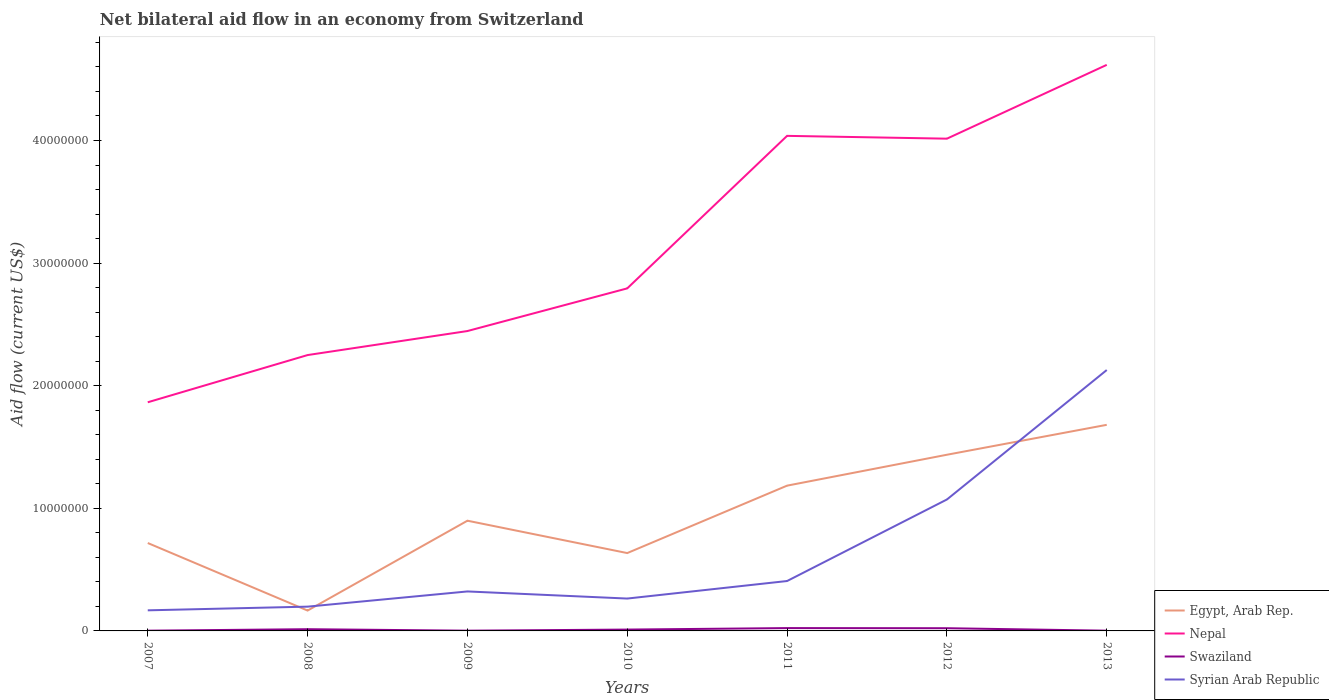How many different coloured lines are there?
Provide a succinct answer. 4. Does the line corresponding to Syrian Arab Republic intersect with the line corresponding to Swaziland?
Ensure brevity in your answer.  No. What is the total net bilateral aid flow in Egypt, Arab Rep. in the graph?
Offer a terse response. -1.82e+06. What is the difference between the highest and the second highest net bilateral aid flow in Egypt, Arab Rep.?
Give a very brief answer. 1.52e+07. Is the net bilateral aid flow in Swaziland strictly greater than the net bilateral aid flow in Egypt, Arab Rep. over the years?
Offer a terse response. Yes. What is the difference between two consecutive major ticks on the Y-axis?
Provide a short and direct response. 1.00e+07. Does the graph contain any zero values?
Give a very brief answer. No. Does the graph contain grids?
Provide a short and direct response. No. How are the legend labels stacked?
Offer a very short reply. Vertical. What is the title of the graph?
Give a very brief answer. Net bilateral aid flow in an economy from Switzerland. What is the Aid flow (current US$) of Egypt, Arab Rep. in 2007?
Give a very brief answer. 7.17e+06. What is the Aid flow (current US$) of Nepal in 2007?
Provide a short and direct response. 1.86e+07. What is the Aid flow (current US$) of Swaziland in 2007?
Give a very brief answer. 2.00e+04. What is the Aid flow (current US$) in Syrian Arab Republic in 2007?
Make the answer very short. 1.68e+06. What is the Aid flow (current US$) of Egypt, Arab Rep. in 2008?
Keep it short and to the point. 1.66e+06. What is the Aid flow (current US$) in Nepal in 2008?
Give a very brief answer. 2.25e+07. What is the Aid flow (current US$) of Syrian Arab Republic in 2008?
Provide a succinct answer. 1.98e+06. What is the Aid flow (current US$) of Egypt, Arab Rep. in 2009?
Keep it short and to the point. 8.99e+06. What is the Aid flow (current US$) in Nepal in 2009?
Offer a very short reply. 2.45e+07. What is the Aid flow (current US$) of Swaziland in 2009?
Make the answer very short. 2.00e+04. What is the Aid flow (current US$) of Syrian Arab Republic in 2009?
Provide a succinct answer. 3.22e+06. What is the Aid flow (current US$) in Egypt, Arab Rep. in 2010?
Provide a short and direct response. 6.35e+06. What is the Aid flow (current US$) in Nepal in 2010?
Your answer should be compact. 2.79e+07. What is the Aid flow (current US$) in Syrian Arab Republic in 2010?
Keep it short and to the point. 2.64e+06. What is the Aid flow (current US$) in Egypt, Arab Rep. in 2011?
Your response must be concise. 1.18e+07. What is the Aid flow (current US$) of Nepal in 2011?
Your answer should be very brief. 4.04e+07. What is the Aid flow (current US$) of Syrian Arab Republic in 2011?
Your answer should be very brief. 4.07e+06. What is the Aid flow (current US$) of Egypt, Arab Rep. in 2012?
Offer a very short reply. 1.44e+07. What is the Aid flow (current US$) in Nepal in 2012?
Your answer should be very brief. 4.02e+07. What is the Aid flow (current US$) in Swaziland in 2012?
Your answer should be very brief. 2.20e+05. What is the Aid flow (current US$) in Syrian Arab Republic in 2012?
Provide a succinct answer. 1.07e+07. What is the Aid flow (current US$) of Egypt, Arab Rep. in 2013?
Provide a succinct answer. 1.68e+07. What is the Aid flow (current US$) of Nepal in 2013?
Provide a succinct answer. 4.62e+07. What is the Aid flow (current US$) of Swaziland in 2013?
Your answer should be compact. 2.00e+04. What is the Aid flow (current US$) of Syrian Arab Republic in 2013?
Your answer should be compact. 2.13e+07. Across all years, what is the maximum Aid flow (current US$) of Egypt, Arab Rep.?
Your answer should be compact. 1.68e+07. Across all years, what is the maximum Aid flow (current US$) of Nepal?
Offer a terse response. 4.62e+07. Across all years, what is the maximum Aid flow (current US$) of Syrian Arab Republic?
Make the answer very short. 2.13e+07. Across all years, what is the minimum Aid flow (current US$) of Egypt, Arab Rep.?
Offer a very short reply. 1.66e+06. Across all years, what is the minimum Aid flow (current US$) in Nepal?
Provide a succinct answer. 1.86e+07. Across all years, what is the minimum Aid flow (current US$) of Syrian Arab Republic?
Your answer should be very brief. 1.68e+06. What is the total Aid flow (current US$) of Egypt, Arab Rep. in the graph?
Keep it short and to the point. 6.72e+07. What is the total Aid flow (current US$) in Nepal in the graph?
Ensure brevity in your answer.  2.20e+08. What is the total Aid flow (current US$) in Swaziland in the graph?
Your response must be concise. 7.60e+05. What is the total Aid flow (current US$) in Syrian Arab Republic in the graph?
Offer a very short reply. 4.56e+07. What is the difference between the Aid flow (current US$) in Egypt, Arab Rep. in 2007 and that in 2008?
Give a very brief answer. 5.51e+06. What is the difference between the Aid flow (current US$) in Nepal in 2007 and that in 2008?
Offer a very short reply. -3.85e+06. What is the difference between the Aid flow (current US$) of Swaziland in 2007 and that in 2008?
Provide a short and direct response. -1.20e+05. What is the difference between the Aid flow (current US$) of Syrian Arab Republic in 2007 and that in 2008?
Your answer should be very brief. -3.00e+05. What is the difference between the Aid flow (current US$) of Egypt, Arab Rep. in 2007 and that in 2009?
Ensure brevity in your answer.  -1.82e+06. What is the difference between the Aid flow (current US$) in Nepal in 2007 and that in 2009?
Give a very brief answer. -5.81e+06. What is the difference between the Aid flow (current US$) in Swaziland in 2007 and that in 2009?
Offer a very short reply. 0. What is the difference between the Aid flow (current US$) in Syrian Arab Republic in 2007 and that in 2009?
Provide a succinct answer. -1.54e+06. What is the difference between the Aid flow (current US$) of Egypt, Arab Rep. in 2007 and that in 2010?
Provide a short and direct response. 8.20e+05. What is the difference between the Aid flow (current US$) of Nepal in 2007 and that in 2010?
Provide a succinct answer. -9.29e+06. What is the difference between the Aid flow (current US$) of Swaziland in 2007 and that in 2010?
Provide a succinct answer. -9.00e+04. What is the difference between the Aid flow (current US$) of Syrian Arab Republic in 2007 and that in 2010?
Make the answer very short. -9.60e+05. What is the difference between the Aid flow (current US$) in Egypt, Arab Rep. in 2007 and that in 2011?
Your answer should be very brief. -4.68e+06. What is the difference between the Aid flow (current US$) of Nepal in 2007 and that in 2011?
Your answer should be very brief. -2.17e+07. What is the difference between the Aid flow (current US$) in Swaziland in 2007 and that in 2011?
Offer a very short reply. -2.10e+05. What is the difference between the Aid flow (current US$) in Syrian Arab Republic in 2007 and that in 2011?
Offer a terse response. -2.39e+06. What is the difference between the Aid flow (current US$) of Egypt, Arab Rep. in 2007 and that in 2012?
Your answer should be very brief. -7.20e+06. What is the difference between the Aid flow (current US$) in Nepal in 2007 and that in 2012?
Provide a succinct answer. -2.15e+07. What is the difference between the Aid flow (current US$) in Swaziland in 2007 and that in 2012?
Offer a terse response. -2.00e+05. What is the difference between the Aid flow (current US$) in Syrian Arab Republic in 2007 and that in 2012?
Make the answer very short. -9.04e+06. What is the difference between the Aid flow (current US$) of Egypt, Arab Rep. in 2007 and that in 2013?
Make the answer very short. -9.64e+06. What is the difference between the Aid flow (current US$) of Nepal in 2007 and that in 2013?
Give a very brief answer. -2.75e+07. What is the difference between the Aid flow (current US$) in Syrian Arab Republic in 2007 and that in 2013?
Provide a short and direct response. -1.96e+07. What is the difference between the Aid flow (current US$) in Egypt, Arab Rep. in 2008 and that in 2009?
Offer a terse response. -7.33e+06. What is the difference between the Aid flow (current US$) of Nepal in 2008 and that in 2009?
Keep it short and to the point. -1.96e+06. What is the difference between the Aid flow (current US$) of Swaziland in 2008 and that in 2009?
Provide a short and direct response. 1.20e+05. What is the difference between the Aid flow (current US$) of Syrian Arab Republic in 2008 and that in 2009?
Your answer should be very brief. -1.24e+06. What is the difference between the Aid flow (current US$) of Egypt, Arab Rep. in 2008 and that in 2010?
Offer a very short reply. -4.69e+06. What is the difference between the Aid flow (current US$) of Nepal in 2008 and that in 2010?
Offer a terse response. -5.44e+06. What is the difference between the Aid flow (current US$) in Swaziland in 2008 and that in 2010?
Ensure brevity in your answer.  3.00e+04. What is the difference between the Aid flow (current US$) of Syrian Arab Republic in 2008 and that in 2010?
Provide a succinct answer. -6.60e+05. What is the difference between the Aid flow (current US$) of Egypt, Arab Rep. in 2008 and that in 2011?
Provide a short and direct response. -1.02e+07. What is the difference between the Aid flow (current US$) of Nepal in 2008 and that in 2011?
Your answer should be very brief. -1.79e+07. What is the difference between the Aid flow (current US$) in Syrian Arab Republic in 2008 and that in 2011?
Provide a short and direct response. -2.09e+06. What is the difference between the Aid flow (current US$) in Egypt, Arab Rep. in 2008 and that in 2012?
Keep it short and to the point. -1.27e+07. What is the difference between the Aid flow (current US$) in Nepal in 2008 and that in 2012?
Ensure brevity in your answer.  -1.76e+07. What is the difference between the Aid flow (current US$) of Swaziland in 2008 and that in 2012?
Keep it short and to the point. -8.00e+04. What is the difference between the Aid flow (current US$) in Syrian Arab Republic in 2008 and that in 2012?
Make the answer very short. -8.74e+06. What is the difference between the Aid flow (current US$) in Egypt, Arab Rep. in 2008 and that in 2013?
Keep it short and to the point. -1.52e+07. What is the difference between the Aid flow (current US$) in Nepal in 2008 and that in 2013?
Provide a short and direct response. -2.37e+07. What is the difference between the Aid flow (current US$) in Swaziland in 2008 and that in 2013?
Offer a terse response. 1.20e+05. What is the difference between the Aid flow (current US$) in Syrian Arab Republic in 2008 and that in 2013?
Ensure brevity in your answer.  -1.93e+07. What is the difference between the Aid flow (current US$) of Egypt, Arab Rep. in 2009 and that in 2010?
Your response must be concise. 2.64e+06. What is the difference between the Aid flow (current US$) of Nepal in 2009 and that in 2010?
Ensure brevity in your answer.  -3.48e+06. What is the difference between the Aid flow (current US$) in Syrian Arab Republic in 2009 and that in 2010?
Offer a terse response. 5.80e+05. What is the difference between the Aid flow (current US$) of Egypt, Arab Rep. in 2009 and that in 2011?
Your answer should be compact. -2.86e+06. What is the difference between the Aid flow (current US$) of Nepal in 2009 and that in 2011?
Ensure brevity in your answer.  -1.59e+07. What is the difference between the Aid flow (current US$) in Swaziland in 2009 and that in 2011?
Ensure brevity in your answer.  -2.10e+05. What is the difference between the Aid flow (current US$) in Syrian Arab Republic in 2009 and that in 2011?
Give a very brief answer. -8.50e+05. What is the difference between the Aid flow (current US$) in Egypt, Arab Rep. in 2009 and that in 2012?
Keep it short and to the point. -5.38e+06. What is the difference between the Aid flow (current US$) in Nepal in 2009 and that in 2012?
Offer a terse response. -1.57e+07. What is the difference between the Aid flow (current US$) in Syrian Arab Republic in 2009 and that in 2012?
Give a very brief answer. -7.50e+06. What is the difference between the Aid flow (current US$) in Egypt, Arab Rep. in 2009 and that in 2013?
Keep it short and to the point. -7.82e+06. What is the difference between the Aid flow (current US$) in Nepal in 2009 and that in 2013?
Offer a terse response. -2.17e+07. What is the difference between the Aid flow (current US$) of Syrian Arab Republic in 2009 and that in 2013?
Your response must be concise. -1.81e+07. What is the difference between the Aid flow (current US$) of Egypt, Arab Rep. in 2010 and that in 2011?
Give a very brief answer. -5.50e+06. What is the difference between the Aid flow (current US$) of Nepal in 2010 and that in 2011?
Your answer should be very brief. -1.24e+07. What is the difference between the Aid flow (current US$) of Syrian Arab Republic in 2010 and that in 2011?
Ensure brevity in your answer.  -1.43e+06. What is the difference between the Aid flow (current US$) of Egypt, Arab Rep. in 2010 and that in 2012?
Ensure brevity in your answer.  -8.02e+06. What is the difference between the Aid flow (current US$) of Nepal in 2010 and that in 2012?
Your response must be concise. -1.22e+07. What is the difference between the Aid flow (current US$) in Swaziland in 2010 and that in 2012?
Provide a succinct answer. -1.10e+05. What is the difference between the Aid flow (current US$) of Syrian Arab Republic in 2010 and that in 2012?
Keep it short and to the point. -8.08e+06. What is the difference between the Aid flow (current US$) of Egypt, Arab Rep. in 2010 and that in 2013?
Provide a succinct answer. -1.05e+07. What is the difference between the Aid flow (current US$) in Nepal in 2010 and that in 2013?
Offer a terse response. -1.82e+07. What is the difference between the Aid flow (current US$) in Syrian Arab Republic in 2010 and that in 2013?
Offer a terse response. -1.86e+07. What is the difference between the Aid flow (current US$) of Egypt, Arab Rep. in 2011 and that in 2012?
Ensure brevity in your answer.  -2.52e+06. What is the difference between the Aid flow (current US$) of Syrian Arab Republic in 2011 and that in 2012?
Keep it short and to the point. -6.65e+06. What is the difference between the Aid flow (current US$) of Egypt, Arab Rep. in 2011 and that in 2013?
Provide a succinct answer. -4.96e+06. What is the difference between the Aid flow (current US$) in Nepal in 2011 and that in 2013?
Your answer should be very brief. -5.79e+06. What is the difference between the Aid flow (current US$) in Syrian Arab Republic in 2011 and that in 2013?
Provide a short and direct response. -1.72e+07. What is the difference between the Aid flow (current US$) in Egypt, Arab Rep. in 2012 and that in 2013?
Provide a short and direct response. -2.44e+06. What is the difference between the Aid flow (current US$) of Nepal in 2012 and that in 2013?
Offer a terse response. -6.02e+06. What is the difference between the Aid flow (current US$) in Swaziland in 2012 and that in 2013?
Your response must be concise. 2.00e+05. What is the difference between the Aid flow (current US$) in Syrian Arab Republic in 2012 and that in 2013?
Your response must be concise. -1.06e+07. What is the difference between the Aid flow (current US$) in Egypt, Arab Rep. in 2007 and the Aid flow (current US$) in Nepal in 2008?
Provide a short and direct response. -1.53e+07. What is the difference between the Aid flow (current US$) of Egypt, Arab Rep. in 2007 and the Aid flow (current US$) of Swaziland in 2008?
Your response must be concise. 7.03e+06. What is the difference between the Aid flow (current US$) in Egypt, Arab Rep. in 2007 and the Aid flow (current US$) in Syrian Arab Republic in 2008?
Your answer should be very brief. 5.19e+06. What is the difference between the Aid flow (current US$) of Nepal in 2007 and the Aid flow (current US$) of Swaziland in 2008?
Offer a terse response. 1.85e+07. What is the difference between the Aid flow (current US$) in Nepal in 2007 and the Aid flow (current US$) in Syrian Arab Republic in 2008?
Keep it short and to the point. 1.67e+07. What is the difference between the Aid flow (current US$) in Swaziland in 2007 and the Aid flow (current US$) in Syrian Arab Republic in 2008?
Ensure brevity in your answer.  -1.96e+06. What is the difference between the Aid flow (current US$) of Egypt, Arab Rep. in 2007 and the Aid flow (current US$) of Nepal in 2009?
Keep it short and to the point. -1.73e+07. What is the difference between the Aid flow (current US$) in Egypt, Arab Rep. in 2007 and the Aid flow (current US$) in Swaziland in 2009?
Offer a terse response. 7.15e+06. What is the difference between the Aid flow (current US$) of Egypt, Arab Rep. in 2007 and the Aid flow (current US$) of Syrian Arab Republic in 2009?
Your answer should be compact. 3.95e+06. What is the difference between the Aid flow (current US$) of Nepal in 2007 and the Aid flow (current US$) of Swaziland in 2009?
Make the answer very short. 1.86e+07. What is the difference between the Aid flow (current US$) of Nepal in 2007 and the Aid flow (current US$) of Syrian Arab Republic in 2009?
Offer a terse response. 1.54e+07. What is the difference between the Aid flow (current US$) of Swaziland in 2007 and the Aid flow (current US$) of Syrian Arab Republic in 2009?
Your response must be concise. -3.20e+06. What is the difference between the Aid flow (current US$) of Egypt, Arab Rep. in 2007 and the Aid flow (current US$) of Nepal in 2010?
Make the answer very short. -2.08e+07. What is the difference between the Aid flow (current US$) of Egypt, Arab Rep. in 2007 and the Aid flow (current US$) of Swaziland in 2010?
Provide a short and direct response. 7.06e+06. What is the difference between the Aid flow (current US$) in Egypt, Arab Rep. in 2007 and the Aid flow (current US$) in Syrian Arab Republic in 2010?
Your response must be concise. 4.53e+06. What is the difference between the Aid flow (current US$) in Nepal in 2007 and the Aid flow (current US$) in Swaziland in 2010?
Make the answer very short. 1.85e+07. What is the difference between the Aid flow (current US$) in Nepal in 2007 and the Aid flow (current US$) in Syrian Arab Republic in 2010?
Ensure brevity in your answer.  1.60e+07. What is the difference between the Aid flow (current US$) in Swaziland in 2007 and the Aid flow (current US$) in Syrian Arab Republic in 2010?
Make the answer very short. -2.62e+06. What is the difference between the Aid flow (current US$) in Egypt, Arab Rep. in 2007 and the Aid flow (current US$) in Nepal in 2011?
Your answer should be compact. -3.32e+07. What is the difference between the Aid flow (current US$) of Egypt, Arab Rep. in 2007 and the Aid flow (current US$) of Swaziland in 2011?
Ensure brevity in your answer.  6.94e+06. What is the difference between the Aid flow (current US$) in Egypt, Arab Rep. in 2007 and the Aid flow (current US$) in Syrian Arab Republic in 2011?
Offer a terse response. 3.10e+06. What is the difference between the Aid flow (current US$) in Nepal in 2007 and the Aid flow (current US$) in Swaziland in 2011?
Offer a very short reply. 1.84e+07. What is the difference between the Aid flow (current US$) in Nepal in 2007 and the Aid flow (current US$) in Syrian Arab Republic in 2011?
Give a very brief answer. 1.46e+07. What is the difference between the Aid flow (current US$) in Swaziland in 2007 and the Aid flow (current US$) in Syrian Arab Republic in 2011?
Provide a succinct answer. -4.05e+06. What is the difference between the Aid flow (current US$) of Egypt, Arab Rep. in 2007 and the Aid flow (current US$) of Nepal in 2012?
Give a very brief answer. -3.30e+07. What is the difference between the Aid flow (current US$) of Egypt, Arab Rep. in 2007 and the Aid flow (current US$) of Swaziland in 2012?
Provide a succinct answer. 6.95e+06. What is the difference between the Aid flow (current US$) of Egypt, Arab Rep. in 2007 and the Aid flow (current US$) of Syrian Arab Republic in 2012?
Provide a short and direct response. -3.55e+06. What is the difference between the Aid flow (current US$) in Nepal in 2007 and the Aid flow (current US$) in Swaziland in 2012?
Your response must be concise. 1.84e+07. What is the difference between the Aid flow (current US$) of Nepal in 2007 and the Aid flow (current US$) of Syrian Arab Republic in 2012?
Your response must be concise. 7.93e+06. What is the difference between the Aid flow (current US$) in Swaziland in 2007 and the Aid flow (current US$) in Syrian Arab Republic in 2012?
Offer a very short reply. -1.07e+07. What is the difference between the Aid flow (current US$) of Egypt, Arab Rep. in 2007 and the Aid flow (current US$) of Nepal in 2013?
Give a very brief answer. -3.90e+07. What is the difference between the Aid flow (current US$) of Egypt, Arab Rep. in 2007 and the Aid flow (current US$) of Swaziland in 2013?
Offer a terse response. 7.15e+06. What is the difference between the Aid flow (current US$) of Egypt, Arab Rep. in 2007 and the Aid flow (current US$) of Syrian Arab Republic in 2013?
Make the answer very short. -1.41e+07. What is the difference between the Aid flow (current US$) of Nepal in 2007 and the Aid flow (current US$) of Swaziland in 2013?
Your answer should be compact. 1.86e+07. What is the difference between the Aid flow (current US$) of Nepal in 2007 and the Aid flow (current US$) of Syrian Arab Republic in 2013?
Provide a short and direct response. -2.63e+06. What is the difference between the Aid flow (current US$) in Swaziland in 2007 and the Aid flow (current US$) in Syrian Arab Republic in 2013?
Keep it short and to the point. -2.13e+07. What is the difference between the Aid flow (current US$) of Egypt, Arab Rep. in 2008 and the Aid flow (current US$) of Nepal in 2009?
Offer a terse response. -2.28e+07. What is the difference between the Aid flow (current US$) of Egypt, Arab Rep. in 2008 and the Aid flow (current US$) of Swaziland in 2009?
Your response must be concise. 1.64e+06. What is the difference between the Aid flow (current US$) in Egypt, Arab Rep. in 2008 and the Aid flow (current US$) in Syrian Arab Republic in 2009?
Provide a succinct answer. -1.56e+06. What is the difference between the Aid flow (current US$) in Nepal in 2008 and the Aid flow (current US$) in Swaziland in 2009?
Your response must be concise. 2.25e+07. What is the difference between the Aid flow (current US$) in Nepal in 2008 and the Aid flow (current US$) in Syrian Arab Republic in 2009?
Your response must be concise. 1.93e+07. What is the difference between the Aid flow (current US$) of Swaziland in 2008 and the Aid flow (current US$) of Syrian Arab Republic in 2009?
Ensure brevity in your answer.  -3.08e+06. What is the difference between the Aid flow (current US$) in Egypt, Arab Rep. in 2008 and the Aid flow (current US$) in Nepal in 2010?
Offer a terse response. -2.63e+07. What is the difference between the Aid flow (current US$) in Egypt, Arab Rep. in 2008 and the Aid flow (current US$) in Swaziland in 2010?
Your answer should be very brief. 1.55e+06. What is the difference between the Aid flow (current US$) of Egypt, Arab Rep. in 2008 and the Aid flow (current US$) of Syrian Arab Republic in 2010?
Provide a short and direct response. -9.80e+05. What is the difference between the Aid flow (current US$) of Nepal in 2008 and the Aid flow (current US$) of Swaziland in 2010?
Offer a terse response. 2.24e+07. What is the difference between the Aid flow (current US$) of Nepal in 2008 and the Aid flow (current US$) of Syrian Arab Republic in 2010?
Provide a short and direct response. 1.99e+07. What is the difference between the Aid flow (current US$) of Swaziland in 2008 and the Aid flow (current US$) of Syrian Arab Republic in 2010?
Your response must be concise. -2.50e+06. What is the difference between the Aid flow (current US$) of Egypt, Arab Rep. in 2008 and the Aid flow (current US$) of Nepal in 2011?
Make the answer very short. -3.87e+07. What is the difference between the Aid flow (current US$) of Egypt, Arab Rep. in 2008 and the Aid flow (current US$) of Swaziland in 2011?
Ensure brevity in your answer.  1.43e+06. What is the difference between the Aid flow (current US$) of Egypt, Arab Rep. in 2008 and the Aid flow (current US$) of Syrian Arab Republic in 2011?
Your response must be concise. -2.41e+06. What is the difference between the Aid flow (current US$) in Nepal in 2008 and the Aid flow (current US$) in Swaziland in 2011?
Offer a very short reply. 2.23e+07. What is the difference between the Aid flow (current US$) of Nepal in 2008 and the Aid flow (current US$) of Syrian Arab Republic in 2011?
Give a very brief answer. 1.84e+07. What is the difference between the Aid flow (current US$) in Swaziland in 2008 and the Aid flow (current US$) in Syrian Arab Republic in 2011?
Offer a very short reply. -3.93e+06. What is the difference between the Aid flow (current US$) of Egypt, Arab Rep. in 2008 and the Aid flow (current US$) of Nepal in 2012?
Offer a very short reply. -3.85e+07. What is the difference between the Aid flow (current US$) of Egypt, Arab Rep. in 2008 and the Aid flow (current US$) of Swaziland in 2012?
Your answer should be compact. 1.44e+06. What is the difference between the Aid flow (current US$) of Egypt, Arab Rep. in 2008 and the Aid flow (current US$) of Syrian Arab Republic in 2012?
Your answer should be compact. -9.06e+06. What is the difference between the Aid flow (current US$) of Nepal in 2008 and the Aid flow (current US$) of Swaziland in 2012?
Your answer should be very brief. 2.23e+07. What is the difference between the Aid flow (current US$) in Nepal in 2008 and the Aid flow (current US$) in Syrian Arab Republic in 2012?
Provide a short and direct response. 1.18e+07. What is the difference between the Aid flow (current US$) in Swaziland in 2008 and the Aid flow (current US$) in Syrian Arab Republic in 2012?
Your answer should be compact. -1.06e+07. What is the difference between the Aid flow (current US$) of Egypt, Arab Rep. in 2008 and the Aid flow (current US$) of Nepal in 2013?
Your answer should be compact. -4.45e+07. What is the difference between the Aid flow (current US$) in Egypt, Arab Rep. in 2008 and the Aid flow (current US$) in Swaziland in 2013?
Provide a succinct answer. 1.64e+06. What is the difference between the Aid flow (current US$) in Egypt, Arab Rep. in 2008 and the Aid flow (current US$) in Syrian Arab Republic in 2013?
Your answer should be very brief. -1.96e+07. What is the difference between the Aid flow (current US$) in Nepal in 2008 and the Aid flow (current US$) in Swaziland in 2013?
Your response must be concise. 2.25e+07. What is the difference between the Aid flow (current US$) of Nepal in 2008 and the Aid flow (current US$) of Syrian Arab Republic in 2013?
Make the answer very short. 1.22e+06. What is the difference between the Aid flow (current US$) of Swaziland in 2008 and the Aid flow (current US$) of Syrian Arab Republic in 2013?
Provide a short and direct response. -2.11e+07. What is the difference between the Aid flow (current US$) in Egypt, Arab Rep. in 2009 and the Aid flow (current US$) in Nepal in 2010?
Your response must be concise. -1.90e+07. What is the difference between the Aid flow (current US$) in Egypt, Arab Rep. in 2009 and the Aid flow (current US$) in Swaziland in 2010?
Give a very brief answer. 8.88e+06. What is the difference between the Aid flow (current US$) in Egypt, Arab Rep. in 2009 and the Aid flow (current US$) in Syrian Arab Republic in 2010?
Ensure brevity in your answer.  6.35e+06. What is the difference between the Aid flow (current US$) of Nepal in 2009 and the Aid flow (current US$) of Swaziland in 2010?
Your answer should be very brief. 2.44e+07. What is the difference between the Aid flow (current US$) in Nepal in 2009 and the Aid flow (current US$) in Syrian Arab Republic in 2010?
Give a very brief answer. 2.18e+07. What is the difference between the Aid flow (current US$) in Swaziland in 2009 and the Aid flow (current US$) in Syrian Arab Republic in 2010?
Provide a short and direct response. -2.62e+06. What is the difference between the Aid flow (current US$) in Egypt, Arab Rep. in 2009 and the Aid flow (current US$) in Nepal in 2011?
Ensure brevity in your answer.  -3.14e+07. What is the difference between the Aid flow (current US$) of Egypt, Arab Rep. in 2009 and the Aid flow (current US$) of Swaziland in 2011?
Provide a short and direct response. 8.76e+06. What is the difference between the Aid flow (current US$) in Egypt, Arab Rep. in 2009 and the Aid flow (current US$) in Syrian Arab Republic in 2011?
Your answer should be very brief. 4.92e+06. What is the difference between the Aid flow (current US$) of Nepal in 2009 and the Aid flow (current US$) of Swaziland in 2011?
Provide a succinct answer. 2.42e+07. What is the difference between the Aid flow (current US$) in Nepal in 2009 and the Aid flow (current US$) in Syrian Arab Republic in 2011?
Your answer should be very brief. 2.04e+07. What is the difference between the Aid flow (current US$) of Swaziland in 2009 and the Aid flow (current US$) of Syrian Arab Republic in 2011?
Give a very brief answer. -4.05e+06. What is the difference between the Aid flow (current US$) of Egypt, Arab Rep. in 2009 and the Aid flow (current US$) of Nepal in 2012?
Your answer should be very brief. -3.12e+07. What is the difference between the Aid flow (current US$) in Egypt, Arab Rep. in 2009 and the Aid flow (current US$) in Swaziland in 2012?
Provide a short and direct response. 8.77e+06. What is the difference between the Aid flow (current US$) in Egypt, Arab Rep. in 2009 and the Aid flow (current US$) in Syrian Arab Republic in 2012?
Offer a terse response. -1.73e+06. What is the difference between the Aid flow (current US$) in Nepal in 2009 and the Aid flow (current US$) in Swaziland in 2012?
Offer a very short reply. 2.42e+07. What is the difference between the Aid flow (current US$) of Nepal in 2009 and the Aid flow (current US$) of Syrian Arab Republic in 2012?
Ensure brevity in your answer.  1.37e+07. What is the difference between the Aid flow (current US$) of Swaziland in 2009 and the Aid flow (current US$) of Syrian Arab Republic in 2012?
Ensure brevity in your answer.  -1.07e+07. What is the difference between the Aid flow (current US$) of Egypt, Arab Rep. in 2009 and the Aid flow (current US$) of Nepal in 2013?
Provide a short and direct response. -3.72e+07. What is the difference between the Aid flow (current US$) in Egypt, Arab Rep. in 2009 and the Aid flow (current US$) in Swaziland in 2013?
Provide a short and direct response. 8.97e+06. What is the difference between the Aid flow (current US$) in Egypt, Arab Rep. in 2009 and the Aid flow (current US$) in Syrian Arab Republic in 2013?
Your answer should be compact. -1.23e+07. What is the difference between the Aid flow (current US$) in Nepal in 2009 and the Aid flow (current US$) in Swaziland in 2013?
Ensure brevity in your answer.  2.44e+07. What is the difference between the Aid flow (current US$) in Nepal in 2009 and the Aid flow (current US$) in Syrian Arab Republic in 2013?
Ensure brevity in your answer.  3.18e+06. What is the difference between the Aid flow (current US$) of Swaziland in 2009 and the Aid flow (current US$) of Syrian Arab Republic in 2013?
Provide a succinct answer. -2.13e+07. What is the difference between the Aid flow (current US$) in Egypt, Arab Rep. in 2010 and the Aid flow (current US$) in Nepal in 2011?
Your answer should be compact. -3.40e+07. What is the difference between the Aid flow (current US$) of Egypt, Arab Rep. in 2010 and the Aid flow (current US$) of Swaziland in 2011?
Keep it short and to the point. 6.12e+06. What is the difference between the Aid flow (current US$) of Egypt, Arab Rep. in 2010 and the Aid flow (current US$) of Syrian Arab Republic in 2011?
Keep it short and to the point. 2.28e+06. What is the difference between the Aid flow (current US$) of Nepal in 2010 and the Aid flow (current US$) of Swaziland in 2011?
Offer a terse response. 2.77e+07. What is the difference between the Aid flow (current US$) of Nepal in 2010 and the Aid flow (current US$) of Syrian Arab Republic in 2011?
Provide a succinct answer. 2.39e+07. What is the difference between the Aid flow (current US$) of Swaziland in 2010 and the Aid flow (current US$) of Syrian Arab Republic in 2011?
Keep it short and to the point. -3.96e+06. What is the difference between the Aid flow (current US$) in Egypt, Arab Rep. in 2010 and the Aid flow (current US$) in Nepal in 2012?
Make the answer very short. -3.38e+07. What is the difference between the Aid flow (current US$) of Egypt, Arab Rep. in 2010 and the Aid flow (current US$) of Swaziland in 2012?
Offer a terse response. 6.13e+06. What is the difference between the Aid flow (current US$) in Egypt, Arab Rep. in 2010 and the Aid flow (current US$) in Syrian Arab Republic in 2012?
Provide a short and direct response. -4.37e+06. What is the difference between the Aid flow (current US$) of Nepal in 2010 and the Aid flow (current US$) of Swaziland in 2012?
Your answer should be compact. 2.77e+07. What is the difference between the Aid flow (current US$) of Nepal in 2010 and the Aid flow (current US$) of Syrian Arab Republic in 2012?
Keep it short and to the point. 1.72e+07. What is the difference between the Aid flow (current US$) of Swaziland in 2010 and the Aid flow (current US$) of Syrian Arab Republic in 2012?
Provide a short and direct response. -1.06e+07. What is the difference between the Aid flow (current US$) in Egypt, Arab Rep. in 2010 and the Aid flow (current US$) in Nepal in 2013?
Your answer should be very brief. -3.98e+07. What is the difference between the Aid flow (current US$) of Egypt, Arab Rep. in 2010 and the Aid flow (current US$) of Swaziland in 2013?
Your answer should be very brief. 6.33e+06. What is the difference between the Aid flow (current US$) of Egypt, Arab Rep. in 2010 and the Aid flow (current US$) of Syrian Arab Republic in 2013?
Your answer should be compact. -1.49e+07. What is the difference between the Aid flow (current US$) in Nepal in 2010 and the Aid flow (current US$) in Swaziland in 2013?
Make the answer very short. 2.79e+07. What is the difference between the Aid flow (current US$) of Nepal in 2010 and the Aid flow (current US$) of Syrian Arab Republic in 2013?
Make the answer very short. 6.66e+06. What is the difference between the Aid flow (current US$) in Swaziland in 2010 and the Aid flow (current US$) in Syrian Arab Republic in 2013?
Offer a terse response. -2.12e+07. What is the difference between the Aid flow (current US$) of Egypt, Arab Rep. in 2011 and the Aid flow (current US$) of Nepal in 2012?
Your answer should be compact. -2.83e+07. What is the difference between the Aid flow (current US$) in Egypt, Arab Rep. in 2011 and the Aid flow (current US$) in Swaziland in 2012?
Your answer should be very brief. 1.16e+07. What is the difference between the Aid flow (current US$) in Egypt, Arab Rep. in 2011 and the Aid flow (current US$) in Syrian Arab Republic in 2012?
Give a very brief answer. 1.13e+06. What is the difference between the Aid flow (current US$) in Nepal in 2011 and the Aid flow (current US$) in Swaziland in 2012?
Make the answer very short. 4.02e+07. What is the difference between the Aid flow (current US$) of Nepal in 2011 and the Aid flow (current US$) of Syrian Arab Republic in 2012?
Your response must be concise. 2.97e+07. What is the difference between the Aid flow (current US$) of Swaziland in 2011 and the Aid flow (current US$) of Syrian Arab Republic in 2012?
Provide a short and direct response. -1.05e+07. What is the difference between the Aid flow (current US$) of Egypt, Arab Rep. in 2011 and the Aid flow (current US$) of Nepal in 2013?
Make the answer very short. -3.43e+07. What is the difference between the Aid flow (current US$) of Egypt, Arab Rep. in 2011 and the Aid flow (current US$) of Swaziland in 2013?
Offer a very short reply. 1.18e+07. What is the difference between the Aid flow (current US$) in Egypt, Arab Rep. in 2011 and the Aid flow (current US$) in Syrian Arab Republic in 2013?
Offer a terse response. -9.43e+06. What is the difference between the Aid flow (current US$) of Nepal in 2011 and the Aid flow (current US$) of Swaziland in 2013?
Make the answer very short. 4.04e+07. What is the difference between the Aid flow (current US$) of Nepal in 2011 and the Aid flow (current US$) of Syrian Arab Republic in 2013?
Ensure brevity in your answer.  1.91e+07. What is the difference between the Aid flow (current US$) of Swaziland in 2011 and the Aid flow (current US$) of Syrian Arab Republic in 2013?
Offer a very short reply. -2.10e+07. What is the difference between the Aid flow (current US$) in Egypt, Arab Rep. in 2012 and the Aid flow (current US$) in Nepal in 2013?
Offer a very short reply. -3.18e+07. What is the difference between the Aid flow (current US$) of Egypt, Arab Rep. in 2012 and the Aid flow (current US$) of Swaziland in 2013?
Provide a short and direct response. 1.44e+07. What is the difference between the Aid flow (current US$) of Egypt, Arab Rep. in 2012 and the Aid flow (current US$) of Syrian Arab Republic in 2013?
Your answer should be compact. -6.91e+06. What is the difference between the Aid flow (current US$) in Nepal in 2012 and the Aid flow (current US$) in Swaziland in 2013?
Keep it short and to the point. 4.01e+07. What is the difference between the Aid flow (current US$) in Nepal in 2012 and the Aid flow (current US$) in Syrian Arab Republic in 2013?
Your response must be concise. 1.89e+07. What is the difference between the Aid flow (current US$) in Swaziland in 2012 and the Aid flow (current US$) in Syrian Arab Republic in 2013?
Give a very brief answer. -2.11e+07. What is the average Aid flow (current US$) of Egypt, Arab Rep. per year?
Provide a short and direct response. 9.60e+06. What is the average Aid flow (current US$) in Nepal per year?
Provide a succinct answer. 3.15e+07. What is the average Aid flow (current US$) of Swaziland per year?
Provide a short and direct response. 1.09e+05. What is the average Aid flow (current US$) in Syrian Arab Republic per year?
Keep it short and to the point. 6.51e+06. In the year 2007, what is the difference between the Aid flow (current US$) in Egypt, Arab Rep. and Aid flow (current US$) in Nepal?
Make the answer very short. -1.15e+07. In the year 2007, what is the difference between the Aid flow (current US$) of Egypt, Arab Rep. and Aid flow (current US$) of Swaziland?
Your response must be concise. 7.15e+06. In the year 2007, what is the difference between the Aid flow (current US$) in Egypt, Arab Rep. and Aid flow (current US$) in Syrian Arab Republic?
Keep it short and to the point. 5.49e+06. In the year 2007, what is the difference between the Aid flow (current US$) of Nepal and Aid flow (current US$) of Swaziland?
Keep it short and to the point. 1.86e+07. In the year 2007, what is the difference between the Aid flow (current US$) of Nepal and Aid flow (current US$) of Syrian Arab Republic?
Offer a terse response. 1.70e+07. In the year 2007, what is the difference between the Aid flow (current US$) of Swaziland and Aid flow (current US$) of Syrian Arab Republic?
Your response must be concise. -1.66e+06. In the year 2008, what is the difference between the Aid flow (current US$) in Egypt, Arab Rep. and Aid flow (current US$) in Nepal?
Offer a very short reply. -2.08e+07. In the year 2008, what is the difference between the Aid flow (current US$) of Egypt, Arab Rep. and Aid flow (current US$) of Swaziland?
Your answer should be compact. 1.52e+06. In the year 2008, what is the difference between the Aid flow (current US$) in Egypt, Arab Rep. and Aid flow (current US$) in Syrian Arab Republic?
Give a very brief answer. -3.20e+05. In the year 2008, what is the difference between the Aid flow (current US$) of Nepal and Aid flow (current US$) of Swaziland?
Make the answer very short. 2.24e+07. In the year 2008, what is the difference between the Aid flow (current US$) in Nepal and Aid flow (current US$) in Syrian Arab Republic?
Provide a succinct answer. 2.05e+07. In the year 2008, what is the difference between the Aid flow (current US$) of Swaziland and Aid flow (current US$) of Syrian Arab Republic?
Provide a short and direct response. -1.84e+06. In the year 2009, what is the difference between the Aid flow (current US$) in Egypt, Arab Rep. and Aid flow (current US$) in Nepal?
Make the answer very short. -1.55e+07. In the year 2009, what is the difference between the Aid flow (current US$) of Egypt, Arab Rep. and Aid flow (current US$) of Swaziland?
Offer a very short reply. 8.97e+06. In the year 2009, what is the difference between the Aid flow (current US$) of Egypt, Arab Rep. and Aid flow (current US$) of Syrian Arab Republic?
Offer a terse response. 5.77e+06. In the year 2009, what is the difference between the Aid flow (current US$) of Nepal and Aid flow (current US$) of Swaziland?
Ensure brevity in your answer.  2.44e+07. In the year 2009, what is the difference between the Aid flow (current US$) of Nepal and Aid flow (current US$) of Syrian Arab Republic?
Provide a succinct answer. 2.12e+07. In the year 2009, what is the difference between the Aid flow (current US$) in Swaziland and Aid flow (current US$) in Syrian Arab Republic?
Offer a terse response. -3.20e+06. In the year 2010, what is the difference between the Aid flow (current US$) of Egypt, Arab Rep. and Aid flow (current US$) of Nepal?
Make the answer very short. -2.16e+07. In the year 2010, what is the difference between the Aid flow (current US$) in Egypt, Arab Rep. and Aid flow (current US$) in Swaziland?
Provide a short and direct response. 6.24e+06. In the year 2010, what is the difference between the Aid flow (current US$) in Egypt, Arab Rep. and Aid flow (current US$) in Syrian Arab Republic?
Keep it short and to the point. 3.71e+06. In the year 2010, what is the difference between the Aid flow (current US$) in Nepal and Aid flow (current US$) in Swaziland?
Make the answer very short. 2.78e+07. In the year 2010, what is the difference between the Aid flow (current US$) in Nepal and Aid flow (current US$) in Syrian Arab Republic?
Make the answer very short. 2.53e+07. In the year 2010, what is the difference between the Aid flow (current US$) of Swaziland and Aid flow (current US$) of Syrian Arab Republic?
Provide a succinct answer. -2.53e+06. In the year 2011, what is the difference between the Aid flow (current US$) in Egypt, Arab Rep. and Aid flow (current US$) in Nepal?
Provide a short and direct response. -2.85e+07. In the year 2011, what is the difference between the Aid flow (current US$) of Egypt, Arab Rep. and Aid flow (current US$) of Swaziland?
Your answer should be very brief. 1.16e+07. In the year 2011, what is the difference between the Aid flow (current US$) in Egypt, Arab Rep. and Aid flow (current US$) in Syrian Arab Republic?
Keep it short and to the point. 7.78e+06. In the year 2011, what is the difference between the Aid flow (current US$) in Nepal and Aid flow (current US$) in Swaziland?
Your response must be concise. 4.02e+07. In the year 2011, what is the difference between the Aid flow (current US$) in Nepal and Aid flow (current US$) in Syrian Arab Republic?
Your answer should be very brief. 3.63e+07. In the year 2011, what is the difference between the Aid flow (current US$) in Swaziland and Aid flow (current US$) in Syrian Arab Republic?
Give a very brief answer. -3.84e+06. In the year 2012, what is the difference between the Aid flow (current US$) in Egypt, Arab Rep. and Aid flow (current US$) in Nepal?
Make the answer very short. -2.58e+07. In the year 2012, what is the difference between the Aid flow (current US$) in Egypt, Arab Rep. and Aid flow (current US$) in Swaziland?
Your response must be concise. 1.42e+07. In the year 2012, what is the difference between the Aid flow (current US$) in Egypt, Arab Rep. and Aid flow (current US$) in Syrian Arab Republic?
Keep it short and to the point. 3.65e+06. In the year 2012, what is the difference between the Aid flow (current US$) in Nepal and Aid flow (current US$) in Swaziland?
Provide a short and direct response. 3.99e+07. In the year 2012, what is the difference between the Aid flow (current US$) in Nepal and Aid flow (current US$) in Syrian Arab Republic?
Your response must be concise. 2.94e+07. In the year 2012, what is the difference between the Aid flow (current US$) in Swaziland and Aid flow (current US$) in Syrian Arab Republic?
Give a very brief answer. -1.05e+07. In the year 2013, what is the difference between the Aid flow (current US$) of Egypt, Arab Rep. and Aid flow (current US$) of Nepal?
Your response must be concise. -2.94e+07. In the year 2013, what is the difference between the Aid flow (current US$) of Egypt, Arab Rep. and Aid flow (current US$) of Swaziland?
Keep it short and to the point. 1.68e+07. In the year 2013, what is the difference between the Aid flow (current US$) in Egypt, Arab Rep. and Aid flow (current US$) in Syrian Arab Republic?
Your response must be concise. -4.47e+06. In the year 2013, what is the difference between the Aid flow (current US$) in Nepal and Aid flow (current US$) in Swaziland?
Ensure brevity in your answer.  4.62e+07. In the year 2013, what is the difference between the Aid flow (current US$) in Nepal and Aid flow (current US$) in Syrian Arab Republic?
Give a very brief answer. 2.49e+07. In the year 2013, what is the difference between the Aid flow (current US$) of Swaziland and Aid flow (current US$) of Syrian Arab Republic?
Offer a terse response. -2.13e+07. What is the ratio of the Aid flow (current US$) in Egypt, Arab Rep. in 2007 to that in 2008?
Your response must be concise. 4.32. What is the ratio of the Aid flow (current US$) of Nepal in 2007 to that in 2008?
Your answer should be compact. 0.83. What is the ratio of the Aid flow (current US$) of Swaziland in 2007 to that in 2008?
Your answer should be compact. 0.14. What is the ratio of the Aid flow (current US$) in Syrian Arab Republic in 2007 to that in 2008?
Your answer should be very brief. 0.85. What is the ratio of the Aid flow (current US$) of Egypt, Arab Rep. in 2007 to that in 2009?
Ensure brevity in your answer.  0.8. What is the ratio of the Aid flow (current US$) in Nepal in 2007 to that in 2009?
Your answer should be compact. 0.76. What is the ratio of the Aid flow (current US$) of Syrian Arab Republic in 2007 to that in 2009?
Offer a terse response. 0.52. What is the ratio of the Aid flow (current US$) in Egypt, Arab Rep. in 2007 to that in 2010?
Make the answer very short. 1.13. What is the ratio of the Aid flow (current US$) in Nepal in 2007 to that in 2010?
Provide a short and direct response. 0.67. What is the ratio of the Aid flow (current US$) in Swaziland in 2007 to that in 2010?
Make the answer very short. 0.18. What is the ratio of the Aid flow (current US$) of Syrian Arab Republic in 2007 to that in 2010?
Make the answer very short. 0.64. What is the ratio of the Aid flow (current US$) of Egypt, Arab Rep. in 2007 to that in 2011?
Keep it short and to the point. 0.61. What is the ratio of the Aid flow (current US$) in Nepal in 2007 to that in 2011?
Ensure brevity in your answer.  0.46. What is the ratio of the Aid flow (current US$) of Swaziland in 2007 to that in 2011?
Ensure brevity in your answer.  0.09. What is the ratio of the Aid flow (current US$) in Syrian Arab Republic in 2007 to that in 2011?
Make the answer very short. 0.41. What is the ratio of the Aid flow (current US$) of Egypt, Arab Rep. in 2007 to that in 2012?
Provide a short and direct response. 0.5. What is the ratio of the Aid flow (current US$) of Nepal in 2007 to that in 2012?
Your answer should be compact. 0.46. What is the ratio of the Aid flow (current US$) in Swaziland in 2007 to that in 2012?
Keep it short and to the point. 0.09. What is the ratio of the Aid flow (current US$) of Syrian Arab Republic in 2007 to that in 2012?
Offer a terse response. 0.16. What is the ratio of the Aid flow (current US$) in Egypt, Arab Rep. in 2007 to that in 2013?
Offer a very short reply. 0.43. What is the ratio of the Aid flow (current US$) in Nepal in 2007 to that in 2013?
Give a very brief answer. 0.4. What is the ratio of the Aid flow (current US$) in Syrian Arab Republic in 2007 to that in 2013?
Ensure brevity in your answer.  0.08. What is the ratio of the Aid flow (current US$) in Egypt, Arab Rep. in 2008 to that in 2009?
Your response must be concise. 0.18. What is the ratio of the Aid flow (current US$) of Nepal in 2008 to that in 2009?
Keep it short and to the point. 0.92. What is the ratio of the Aid flow (current US$) of Swaziland in 2008 to that in 2009?
Offer a terse response. 7. What is the ratio of the Aid flow (current US$) of Syrian Arab Republic in 2008 to that in 2009?
Provide a succinct answer. 0.61. What is the ratio of the Aid flow (current US$) of Egypt, Arab Rep. in 2008 to that in 2010?
Your answer should be compact. 0.26. What is the ratio of the Aid flow (current US$) in Nepal in 2008 to that in 2010?
Your answer should be very brief. 0.81. What is the ratio of the Aid flow (current US$) of Swaziland in 2008 to that in 2010?
Offer a terse response. 1.27. What is the ratio of the Aid flow (current US$) in Syrian Arab Republic in 2008 to that in 2010?
Offer a terse response. 0.75. What is the ratio of the Aid flow (current US$) of Egypt, Arab Rep. in 2008 to that in 2011?
Offer a terse response. 0.14. What is the ratio of the Aid flow (current US$) of Nepal in 2008 to that in 2011?
Make the answer very short. 0.56. What is the ratio of the Aid flow (current US$) in Swaziland in 2008 to that in 2011?
Make the answer very short. 0.61. What is the ratio of the Aid flow (current US$) of Syrian Arab Republic in 2008 to that in 2011?
Offer a terse response. 0.49. What is the ratio of the Aid flow (current US$) of Egypt, Arab Rep. in 2008 to that in 2012?
Make the answer very short. 0.12. What is the ratio of the Aid flow (current US$) in Nepal in 2008 to that in 2012?
Provide a succinct answer. 0.56. What is the ratio of the Aid flow (current US$) of Swaziland in 2008 to that in 2012?
Provide a short and direct response. 0.64. What is the ratio of the Aid flow (current US$) in Syrian Arab Republic in 2008 to that in 2012?
Your answer should be compact. 0.18. What is the ratio of the Aid flow (current US$) of Egypt, Arab Rep. in 2008 to that in 2013?
Ensure brevity in your answer.  0.1. What is the ratio of the Aid flow (current US$) in Nepal in 2008 to that in 2013?
Ensure brevity in your answer.  0.49. What is the ratio of the Aid flow (current US$) in Syrian Arab Republic in 2008 to that in 2013?
Ensure brevity in your answer.  0.09. What is the ratio of the Aid flow (current US$) in Egypt, Arab Rep. in 2009 to that in 2010?
Make the answer very short. 1.42. What is the ratio of the Aid flow (current US$) of Nepal in 2009 to that in 2010?
Make the answer very short. 0.88. What is the ratio of the Aid flow (current US$) of Swaziland in 2009 to that in 2010?
Give a very brief answer. 0.18. What is the ratio of the Aid flow (current US$) of Syrian Arab Republic in 2009 to that in 2010?
Your answer should be compact. 1.22. What is the ratio of the Aid flow (current US$) of Egypt, Arab Rep. in 2009 to that in 2011?
Offer a terse response. 0.76. What is the ratio of the Aid flow (current US$) of Nepal in 2009 to that in 2011?
Keep it short and to the point. 0.61. What is the ratio of the Aid flow (current US$) of Swaziland in 2009 to that in 2011?
Offer a terse response. 0.09. What is the ratio of the Aid flow (current US$) in Syrian Arab Republic in 2009 to that in 2011?
Provide a short and direct response. 0.79. What is the ratio of the Aid flow (current US$) in Egypt, Arab Rep. in 2009 to that in 2012?
Make the answer very short. 0.63. What is the ratio of the Aid flow (current US$) of Nepal in 2009 to that in 2012?
Keep it short and to the point. 0.61. What is the ratio of the Aid flow (current US$) in Swaziland in 2009 to that in 2012?
Offer a very short reply. 0.09. What is the ratio of the Aid flow (current US$) in Syrian Arab Republic in 2009 to that in 2012?
Keep it short and to the point. 0.3. What is the ratio of the Aid flow (current US$) in Egypt, Arab Rep. in 2009 to that in 2013?
Provide a succinct answer. 0.53. What is the ratio of the Aid flow (current US$) in Nepal in 2009 to that in 2013?
Keep it short and to the point. 0.53. What is the ratio of the Aid flow (current US$) in Syrian Arab Republic in 2009 to that in 2013?
Your answer should be compact. 0.15. What is the ratio of the Aid flow (current US$) of Egypt, Arab Rep. in 2010 to that in 2011?
Make the answer very short. 0.54. What is the ratio of the Aid flow (current US$) of Nepal in 2010 to that in 2011?
Provide a succinct answer. 0.69. What is the ratio of the Aid flow (current US$) in Swaziland in 2010 to that in 2011?
Provide a short and direct response. 0.48. What is the ratio of the Aid flow (current US$) of Syrian Arab Republic in 2010 to that in 2011?
Your answer should be very brief. 0.65. What is the ratio of the Aid flow (current US$) of Egypt, Arab Rep. in 2010 to that in 2012?
Give a very brief answer. 0.44. What is the ratio of the Aid flow (current US$) of Nepal in 2010 to that in 2012?
Your response must be concise. 0.7. What is the ratio of the Aid flow (current US$) in Swaziland in 2010 to that in 2012?
Your response must be concise. 0.5. What is the ratio of the Aid flow (current US$) of Syrian Arab Republic in 2010 to that in 2012?
Your answer should be compact. 0.25. What is the ratio of the Aid flow (current US$) in Egypt, Arab Rep. in 2010 to that in 2013?
Your answer should be compact. 0.38. What is the ratio of the Aid flow (current US$) of Nepal in 2010 to that in 2013?
Give a very brief answer. 0.61. What is the ratio of the Aid flow (current US$) of Swaziland in 2010 to that in 2013?
Offer a very short reply. 5.5. What is the ratio of the Aid flow (current US$) in Syrian Arab Republic in 2010 to that in 2013?
Your response must be concise. 0.12. What is the ratio of the Aid flow (current US$) in Egypt, Arab Rep. in 2011 to that in 2012?
Make the answer very short. 0.82. What is the ratio of the Aid flow (current US$) in Swaziland in 2011 to that in 2012?
Ensure brevity in your answer.  1.05. What is the ratio of the Aid flow (current US$) in Syrian Arab Republic in 2011 to that in 2012?
Your answer should be compact. 0.38. What is the ratio of the Aid flow (current US$) of Egypt, Arab Rep. in 2011 to that in 2013?
Keep it short and to the point. 0.7. What is the ratio of the Aid flow (current US$) of Nepal in 2011 to that in 2013?
Give a very brief answer. 0.87. What is the ratio of the Aid flow (current US$) in Swaziland in 2011 to that in 2013?
Keep it short and to the point. 11.5. What is the ratio of the Aid flow (current US$) of Syrian Arab Republic in 2011 to that in 2013?
Give a very brief answer. 0.19. What is the ratio of the Aid flow (current US$) of Egypt, Arab Rep. in 2012 to that in 2013?
Your answer should be very brief. 0.85. What is the ratio of the Aid flow (current US$) of Nepal in 2012 to that in 2013?
Provide a short and direct response. 0.87. What is the ratio of the Aid flow (current US$) in Swaziland in 2012 to that in 2013?
Your answer should be compact. 11. What is the ratio of the Aid flow (current US$) in Syrian Arab Republic in 2012 to that in 2013?
Ensure brevity in your answer.  0.5. What is the difference between the highest and the second highest Aid flow (current US$) in Egypt, Arab Rep.?
Your answer should be compact. 2.44e+06. What is the difference between the highest and the second highest Aid flow (current US$) of Nepal?
Make the answer very short. 5.79e+06. What is the difference between the highest and the second highest Aid flow (current US$) in Syrian Arab Republic?
Offer a very short reply. 1.06e+07. What is the difference between the highest and the lowest Aid flow (current US$) in Egypt, Arab Rep.?
Keep it short and to the point. 1.52e+07. What is the difference between the highest and the lowest Aid flow (current US$) in Nepal?
Your response must be concise. 2.75e+07. What is the difference between the highest and the lowest Aid flow (current US$) in Swaziland?
Provide a succinct answer. 2.10e+05. What is the difference between the highest and the lowest Aid flow (current US$) of Syrian Arab Republic?
Provide a short and direct response. 1.96e+07. 